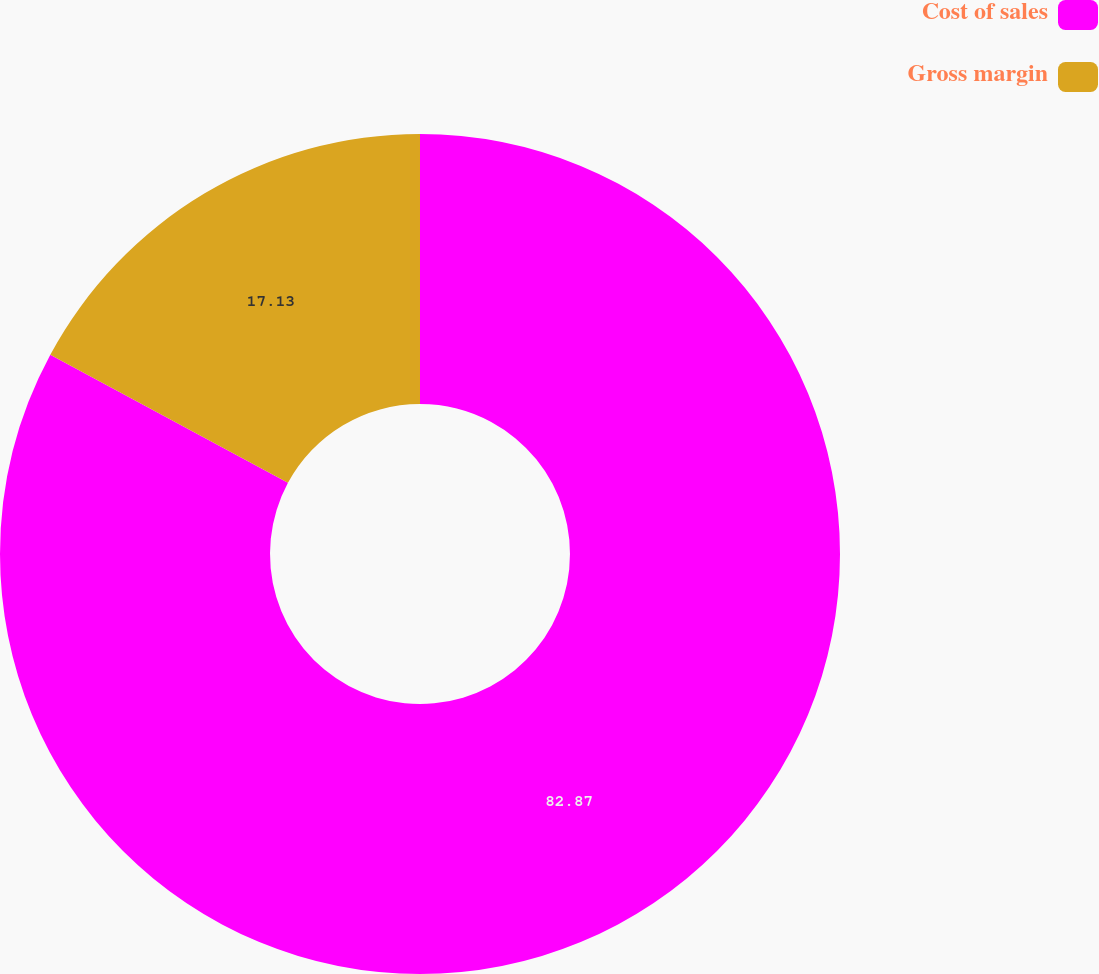Convert chart to OTSL. <chart><loc_0><loc_0><loc_500><loc_500><pie_chart><fcel>Cost of sales<fcel>Gross margin<nl><fcel>82.87%<fcel>17.13%<nl></chart> 